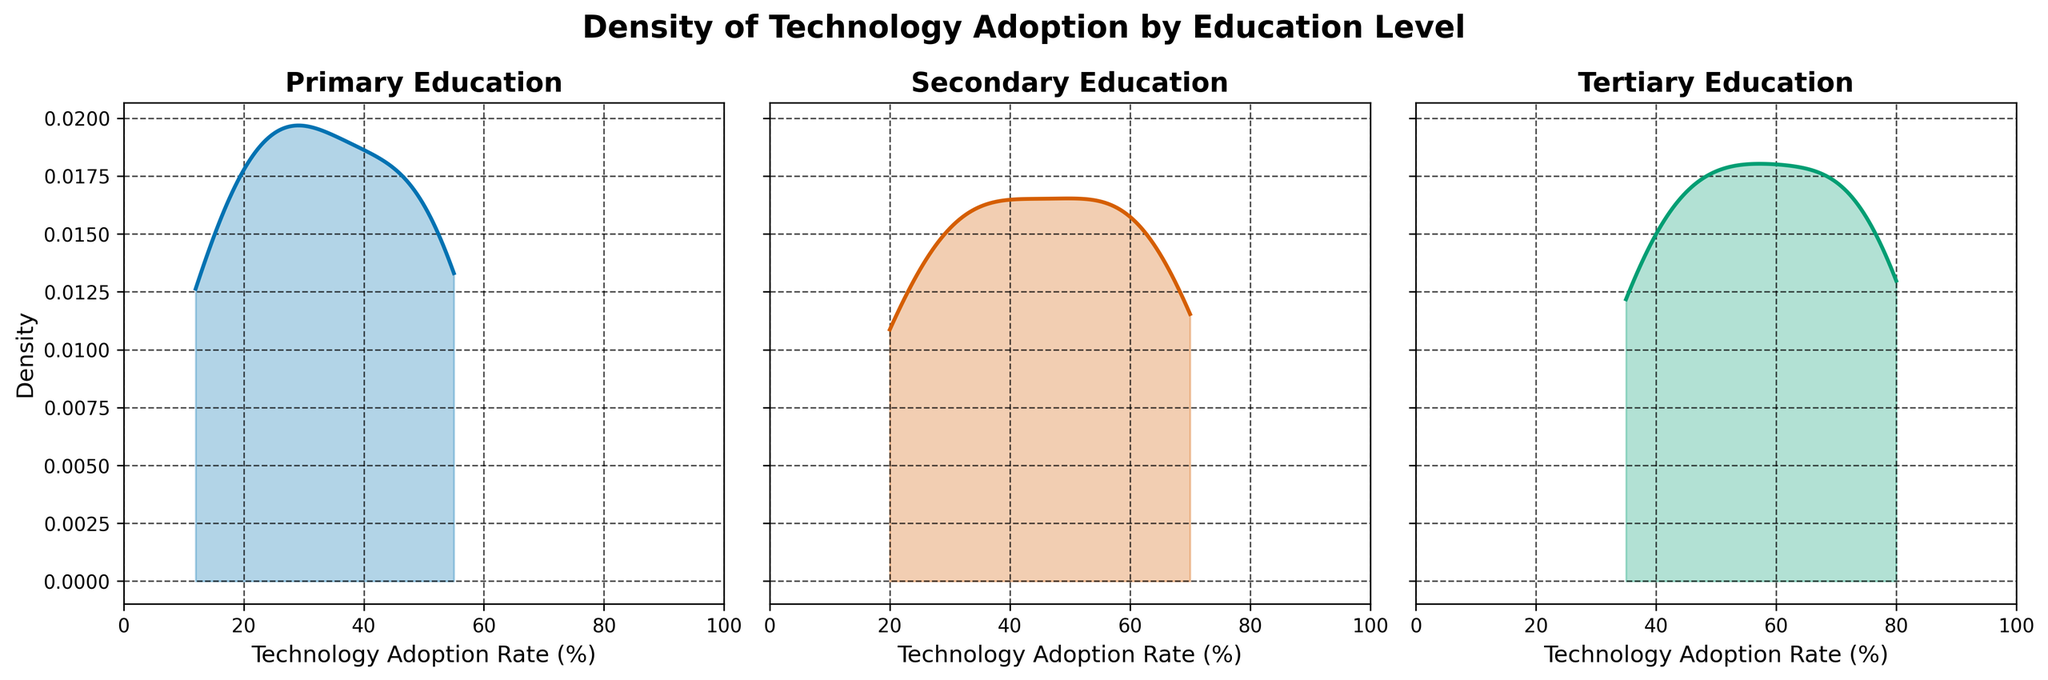Which education level shows the highest peak in their density plot? To find which education level has the highest peak, look at the highest point of each density plot's curve. The education level with the highest y-coordinate value has the highest peak.
Answer: Tertiary Between Primary and Secondary education levels, which has a broader spread in the density plot? The broader spread is indicated by a wider range of x-values where the density plot shows significant density. Compare the x-axis spans of the density plots for Primary and Secondary levels.
Answer: Secondary What is the approximate range of technology adoption for the Tertiary education level? Observe the x-axis range where the Tertiary density plot has notable density. The lowest and highest x-values where the density is not zero define the range.
Answer: 35% to 80% How does the technology adoption density of Secondary education in 2020 compare to Secondary in 2015? Density plots show smoothed distributions over ranges without specific year markers, but general trends can be inferred. Secondary education shows higher adoption in 2020 compared to 2015, indicated by a shift in the curve towards higher x-values.
Answer: Higher in 2020 Which education level shows the least density at the highest technology adoption rate? Look at the rightmost part of each density plot. The education level with the lowest y-value at the right end of the x-axis (highest adoption rate) is the one with the least density there.
Answer: Primary What can be inferred about the maximum technology adoption rate for all education levels? Identify the rightmost points where each density plot has non-zero density. The maximum technology adoption rate is determined by the highest x-value noted across all three plots.
Answer: 80% Between Primary and Tertiary education levels, which density curve has a steeper peak? A steeper peak is indicated by a sharper rise and fall near the peak. Compare the slopes of the curves around their respective peaks for Primary and Tertiary education levels.
Answer: Tertiary Which education level shows a significant increase in density around mid technology adoption rates? Identify the mid portion of the x-axis (around 40%-60%). The densest curve in this region will indicate a significant increase in density for that education level.
Answer: Secondary How does the range of technology adoption for Secondary education compare to Primary education? Compare the x-axis ranges of both density plots. Secondary should be from ~20% to 70%, and Primary from ~12% to 55%. This shows Secondary has a broader range of adoption rates.
Answer: Secondary has a broader range 